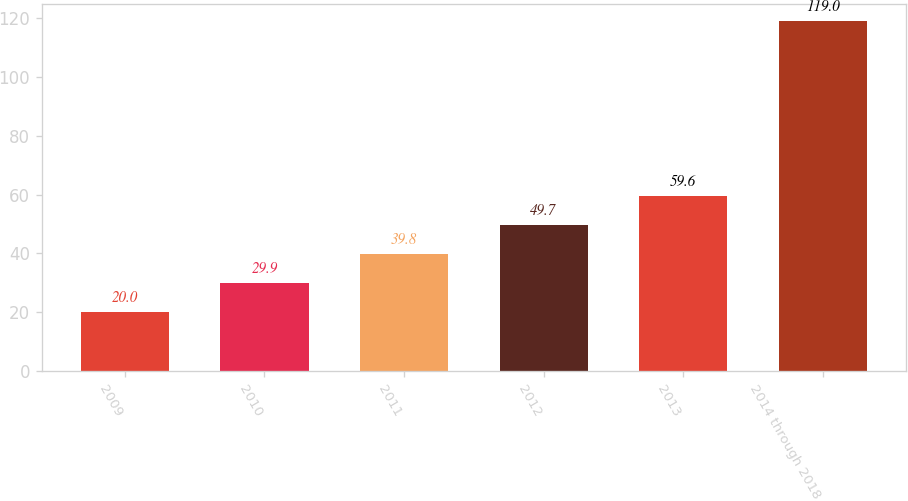Convert chart. <chart><loc_0><loc_0><loc_500><loc_500><bar_chart><fcel>2009<fcel>2010<fcel>2011<fcel>2012<fcel>2013<fcel>2014 through 2018<nl><fcel>20<fcel>29.9<fcel>39.8<fcel>49.7<fcel>59.6<fcel>119<nl></chart> 